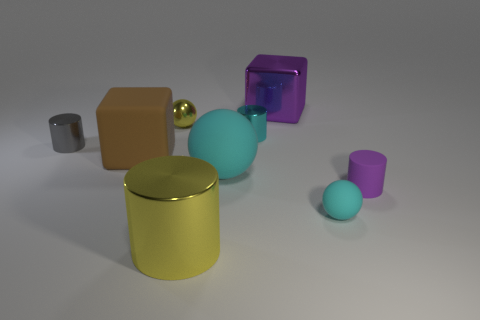Subtract all cyan matte balls. How many balls are left? 1 Subtract all cyan spheres. How many spheres are left? 1 Subtract all spheres. How many objects are left? 6 Subtract 4 cylinders. How many cylinders are left? 0 Subtract all green cylinders. Subtract all purple cubes. How many cylinders are left? 4 Subtract all purple cylinders. How many green spheres are left? 0 Subtract all large red shiny cylinders. Subtract all small gray metal cylinders. How many objects are left? 8 Add 7 tiny purple cylinders. How many tiny purple cylinders are left? 8 Add 6 large purple shiny spheres. How many large purple shiny spheres exist? 6 Subtract 0 blue spheres. How many objects are left? 9 